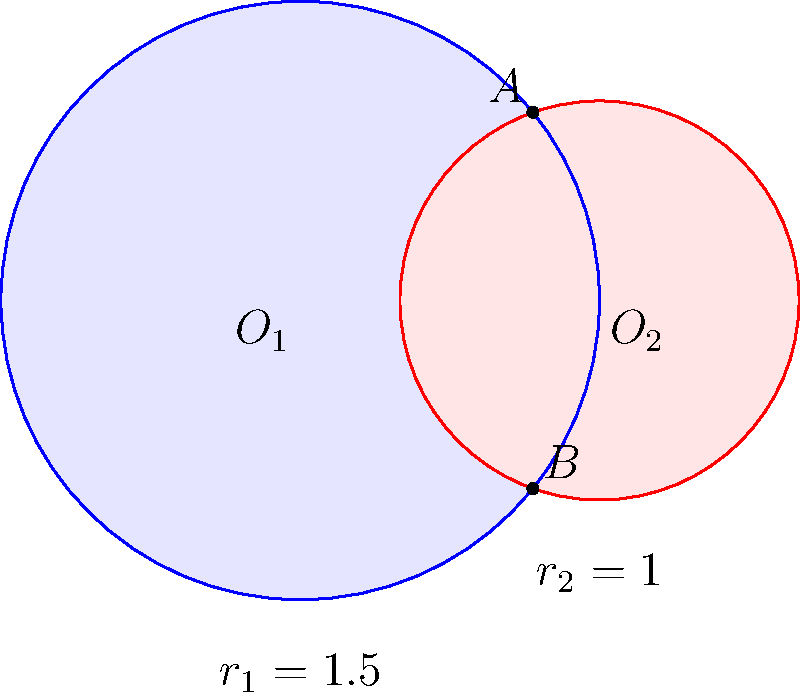In a modern art installation, two circular canvases intersect as shown in the diagram. The blue circle has a radius of 1.5 units and is centered at $O_1$, while the red circle has a radius of 1 unit and is centered at $O_2$. The distance between the centers is 1.5 units. Calculate the area of the overlapping region (lens-shaped area) formed by the intersection of these two circles. Express your answer in terms of π. Let's approach this step-by-step:

1) First, we need to find the central angle of each circle sector. We can do this using the cosine law:

   For $O_1$: $\cos \theta_1 = \frac{1.5^2 + 1.5^2 - 1^2}{2(1.5)(1.5)} = \frac{5}{6}$
   For $O_2$: $\cos \theta_2 = \frac{1.5^2 + 1^2 - 1.5^2}{2(1.5)(1)} = \frac{1}{3}$

2) Calculate the angles:
   $\theta_1 = \arccos(\frac{5}{6}) \approx 0.5904$ radians
   $\theta_2 = \arccos(\frac{1}{3}) \approx 1.2310$ radians

3) The area of each sector is given by $\frac{1}{2}r^2\theta$:
   Area of sector in blue circle: $\frac{1}{2}(1.5)^2(0.5904) = 0.6642$ square units
   Area of sector in red circle: $\frac{1}{2}(1)^2(1.2310) = 0.6155$ square units

4) The area of each triangle formed by the radius to the intersection point and half the line joining the centers:
   Area of triangle = $\frac{1}{2}(1.5)(1)(0.5) = 0.375$ square units

5) The lens-shaped area is the sum of the two sectors minus the two triangles:
   Lens area = $(0.6642 + 0.6155) - 2(0.375) = 0.5297$ square units

6) Express in terms of π:
   $0.5297 \approx \frac{1}{6}\pi$

Thus, the area of the lens-shaped region is approximately $\frac{1}{6}\pi$ square units.
Answer: $\frac{1}{6}\pi$ square units 